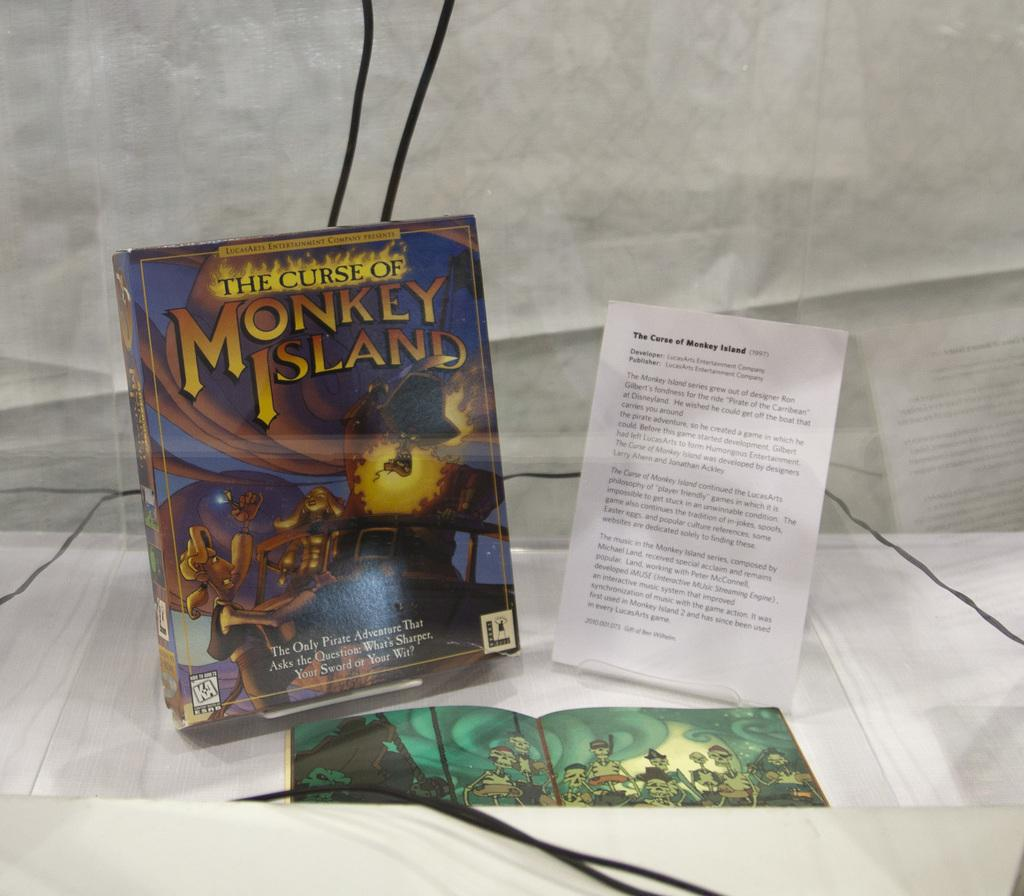<image>
Render a clear and concise summary of the photo. A copy of LucasArts The Curse of Monkey Island is rated KA. 